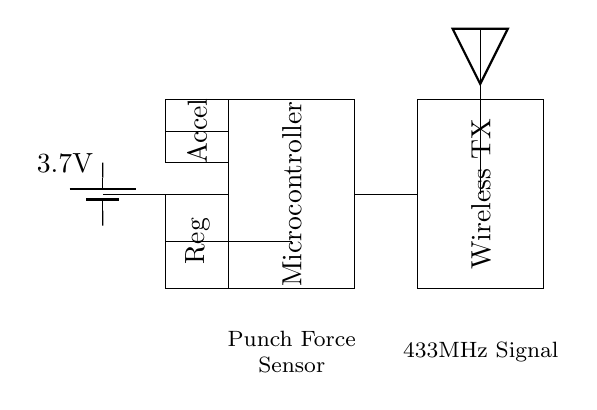What is the primary function of the microcontroller in this circuit? The microcontroller processes the input from sensors, interprets the data, and controls the wireless transmission to communicate with the punching bag system.
Answer: Processing What is the purpose of the accelerometer in this circuit? The accelerometer detects the movement and impact forces generated while engaging with the punching bag, allowing the system to measure performance statistics.
Answer: Measurement What type of signal does the wireless transmitter output? The wireless transmitter emits a signal at 433MHz frequency, which is utilized for sending data wirelessly to the punching bag system.
Answer: 433MHz How many volts does the battery supply? The battery is labeled with a voltage of 3.7V, indicating its output for powering the circuit components.
Answer: 3.7V What component regulates the voltage to the microcontroller? The voltage regulator is positioned in the circuit to ensure the microcontroller receives a stable voltage supply, appropriate for its operation.
Answer: Regulator What is the role of the punch force sensor? The punch force sensor captures the magnitude of the impact from punches delivered to the bag, providing critical feedback on performance to the user.
Answer: Feedback 